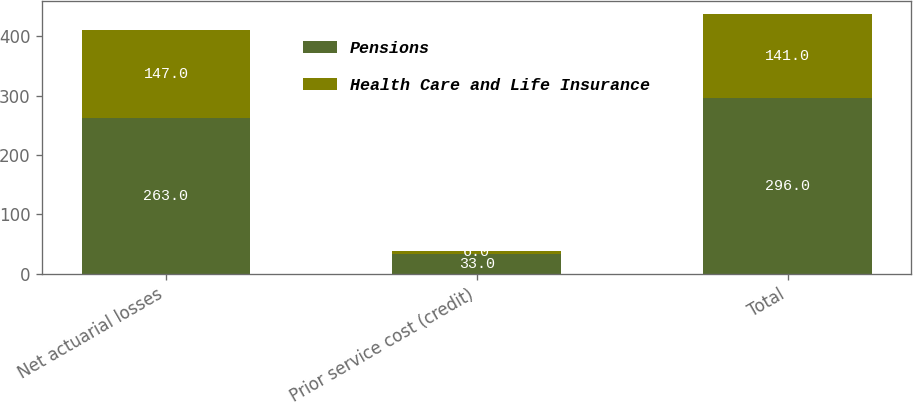Convert chart. <chart><loc_0><loc_0><loc_500><loc_500><stacked_bar_chart><ecel><fcel>Net actuarial losses<fcel>Prior service cost (credit)<fcel>Total<nl><fcel>Pensions<fcel>263<fcel>33<fcel>296<nl><fcel>Health Care and Life Insurance<fcel>147<fcel>6<fcel>141<nl></chart> 